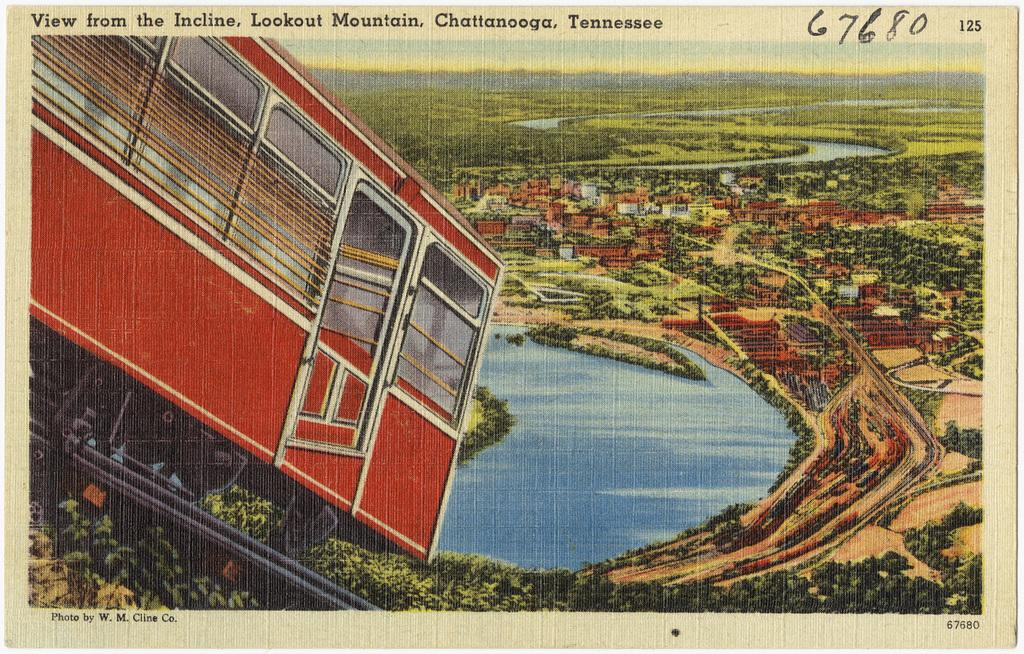<image>
Offer a succinct explanation of the picture presented. A postcard shows the view from a lookout in Chattanooga. 